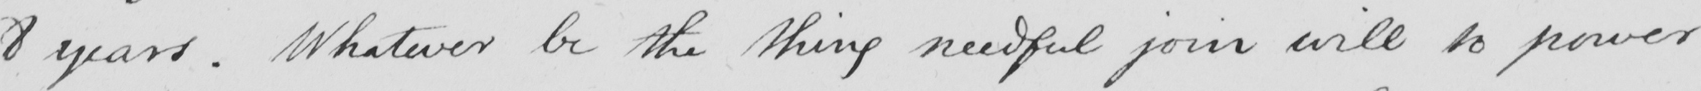Please provide the text content of this handwritten line. 8 years . Whatever be the thing needful join will to power 